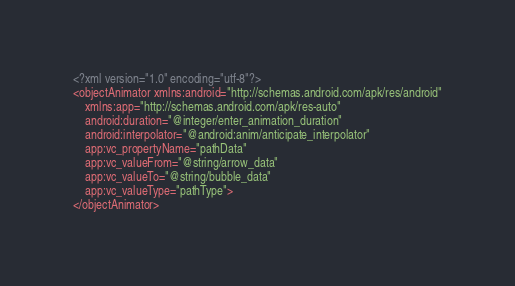Convert code to text. <code><loc_0><loc_0><loc_500><loc_500><_XML_><?xml version="1.0" encoding="utf-8"?>
<objectAnimator xmlns:android="http://schemas.android.com/apk/res/android"
    xmlns:app="http://schemas.android.com/apk/res-auto"
    android:duration="@integer/enter_animation_duration"
    android:interpolator="@android:anim/anticipate_interpolator"
    app:vc_propertyName="pathData"
    app:vc_valueFrom="@string/arrow_data"
    app:vc_valueTo="@string/bubble_data"
    app:vc_valueType="pathType">
</objectAnimator>
</code> 